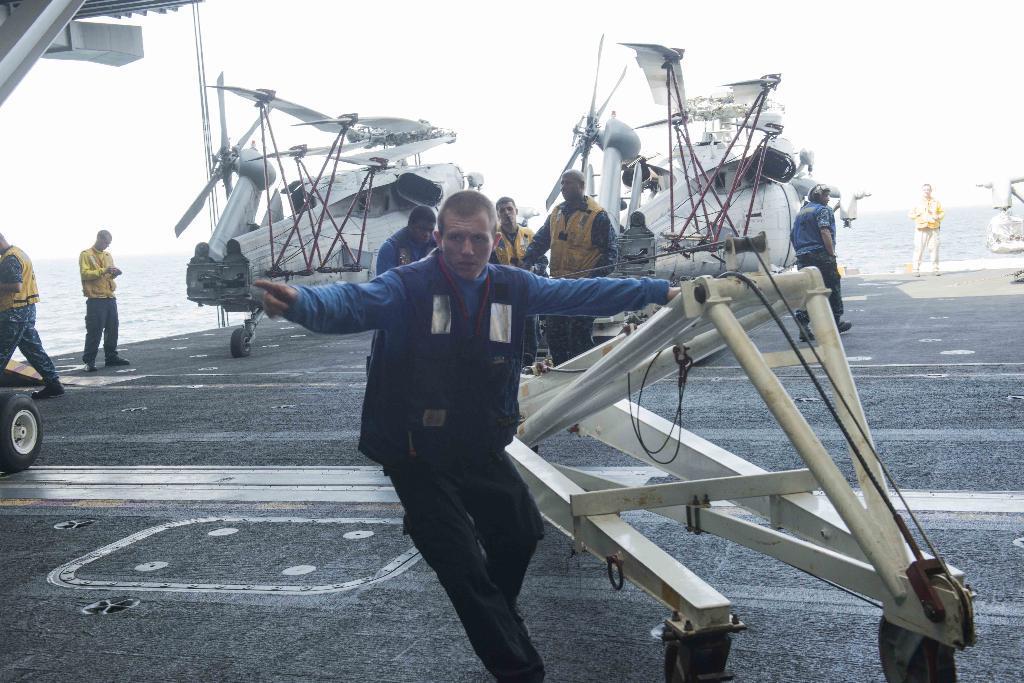Describe this image in one or two sentences. This picture is clicked outside. In the center there is a person holding an object and walking on the ground. In the background we can see the aircraft, metal rods, group of persons, water body and the sky. 